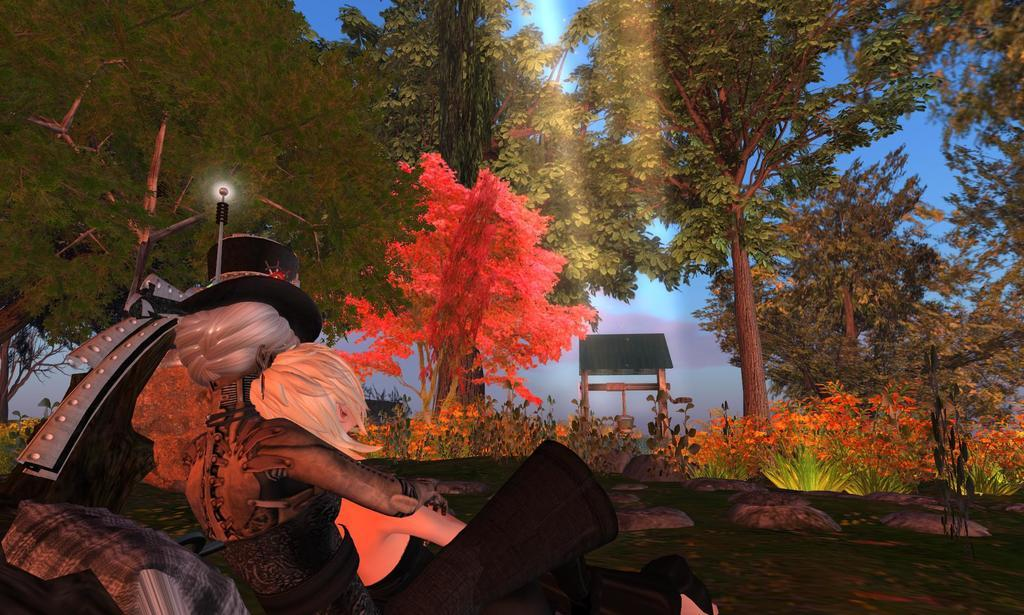What type of image is being described? The image is animated. How many people are present in the image? There are two persons in the image. What type of natural elements can be seen in the image? There are trees and plants in the image. What object is associated with the bucket in the image? There is a rope attached to the bucket in the image. What is visible in the background of the image? Sky is visible in the background of the image. Where is the desk located in the image? There is no desk present in the image. What type of spider web can be seen in the image? There is no spider web, or cobweb, present in the image. 